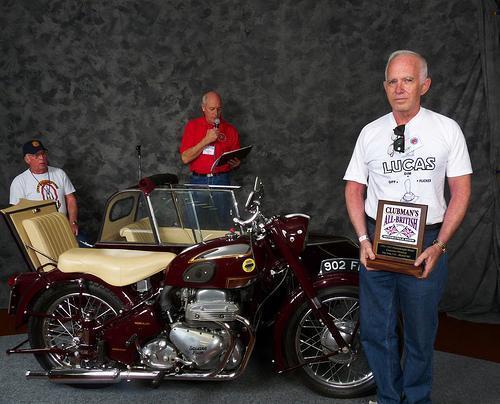How many men are in this picture?
Give a very brief answer. 3. 